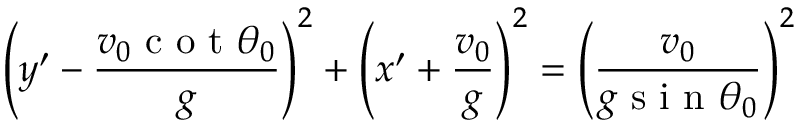Convert formula to latex. <formula><loc_0><loc_0><loc_500><loc_500>\left ( y ^ { \prime } - \frac { v _ { 0 } c o t \theta _ { 0 } } { g } \right ) ^ { 2 } + \left ( x ^ { \prime } + \frac { v _ { 0 } } { g } \right ) ^ { 2 } = \left ( \frac { v _ { 0 } } { g \sin \theta _ { 0 } } \right ) ^ { 2 }</formula> 